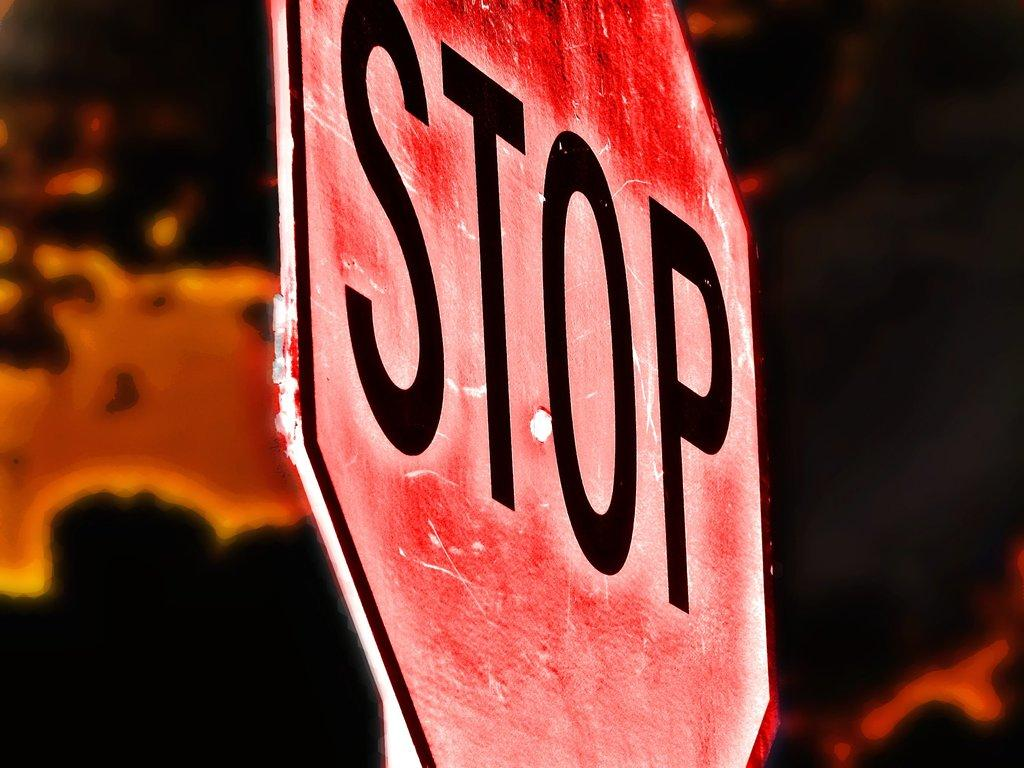<image>
Write a terse but informative summary of the picture. A red sign has the word STOP painted on it. 